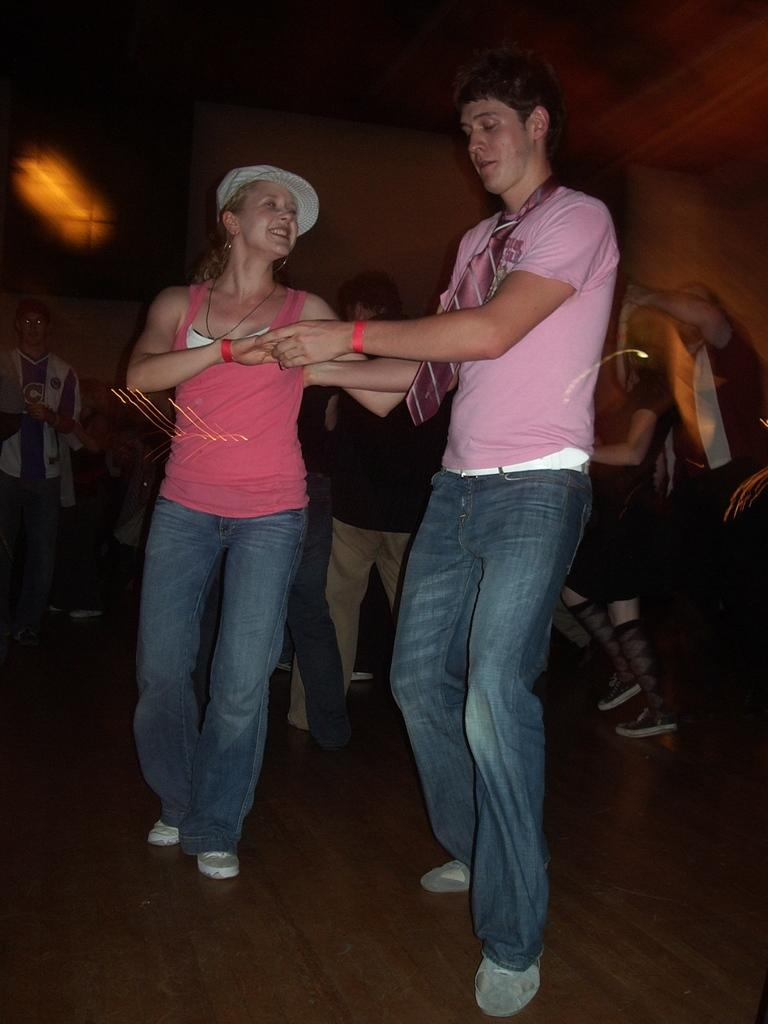What is the gender of the person standing in the image? There is a man standing in the image. What is the man wearing in the image? The man is wearing a pink shirt. What is the woman doing in the image? The woman is smiling. How many people are standing in the background of the image? There is a group of people standing at the back of the image. What type of clouds can be seen in the image? There are no clouds visible in the image; it features people standing and smiling. 